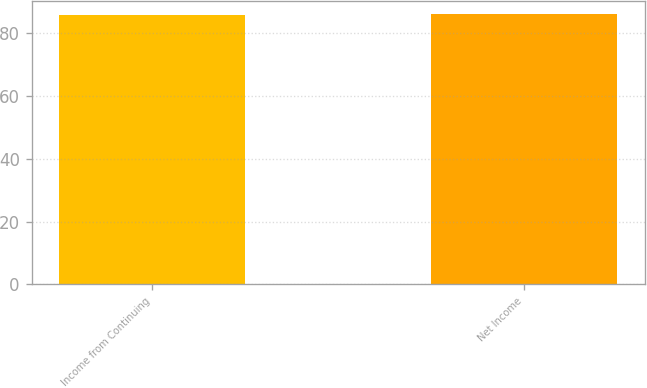Convert chart. <chart><loc_0><loc_0><loc_500><loc_500><bar_chart><fcel>Income from Continuing<fcel>Net Income<nl><fcel>86<fcel>86.1<nl></chart> 